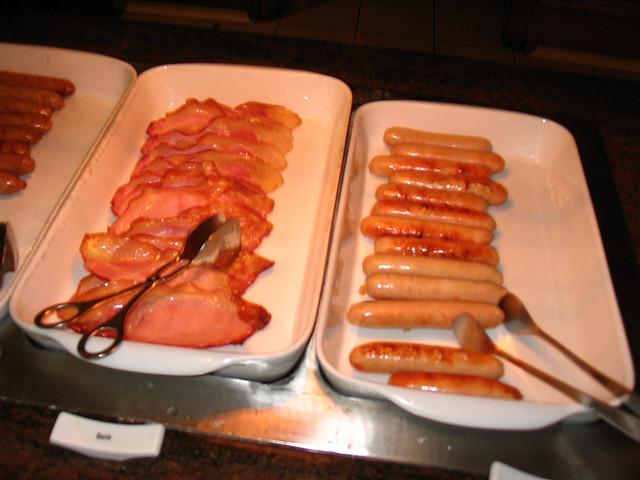What meats are shown?
Quick response, please. Hot dogs and ham. Is this a buffet?
Be succinct. Yes. What are made of metal?
Keep it brief. Tongs. 